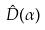<formula> <loc_0><loc_0><loc_500><loc_500>\hat { D } ( \alpha )</formula> 